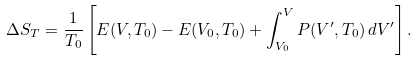Convert formula to latex. <formula><loc_0><loc_0><loc_500><loc_500>\Delta S _ { T } = \frac { 1 } { T _ { 0 } } \left [ E ( V , T _ { 0 } ) - E ( V _ { 0 } , T _ { 0 } ) + \int _ { V _ { 0 } } ^ { V } P ( V ^ { \prime } , T _ { 0 } ) \, d V ^ { \prime } \right ] .</formula> 